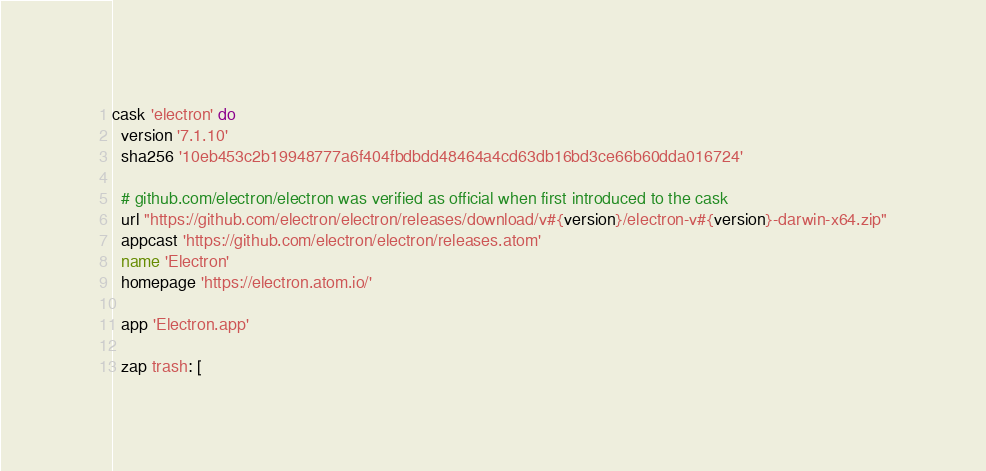Convert code to text. <code><loc_0><loc_0><loc_500><loc_500><_Ruby_>cask 'electron' do
  version '7.1.10'
  sha256 '10eb453c2b19948777a6f404fbdbdd48464a4cd63db16bd3ce66b60dda016724'

  # github.com/electron/electron was verified as official when first introduced to the cask
  url "https://github.com/electron/electron/releases/download/v#{version}/electron-v#{version}-darwin-x64.zip"
  appcast 'https://github.com/electron/electron/releases.atom'
  name 'Electron'
  homepage 'https://electron.atom.io/'

  app 'Electron.app'

  zap trash: [</code> 